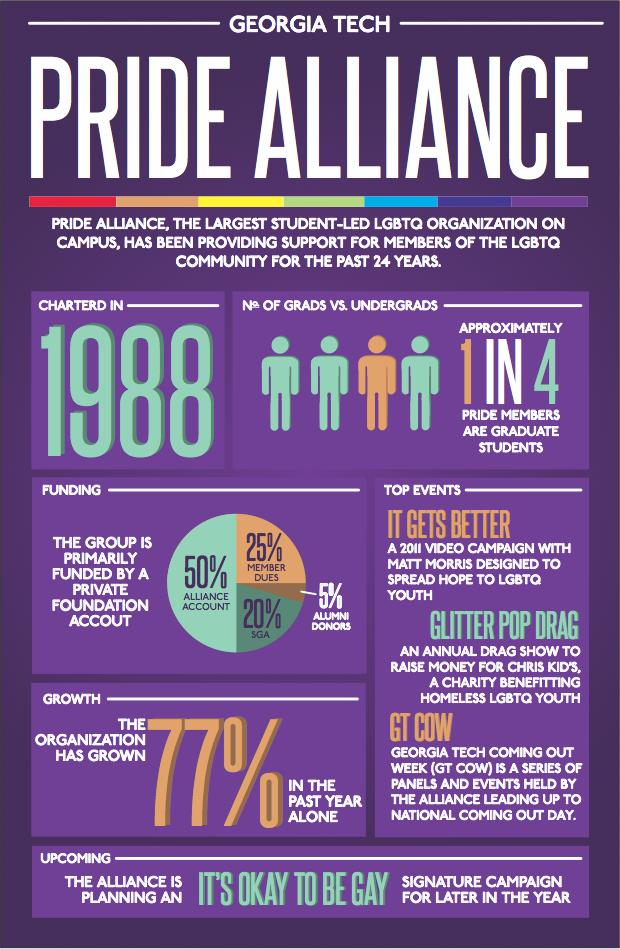List a handful of essential elements in this visual. Alliance Account is the largest financial supporter of Pride Alliance. Pride Alliance is funded by a small percentage of alumni donors, specifically 5%. There are approximately 3 LGBTQ community members who are currently undergraduates. According to recent data, approximately 20% of Pride Alliance's funding is provided by the Student Government Association. 